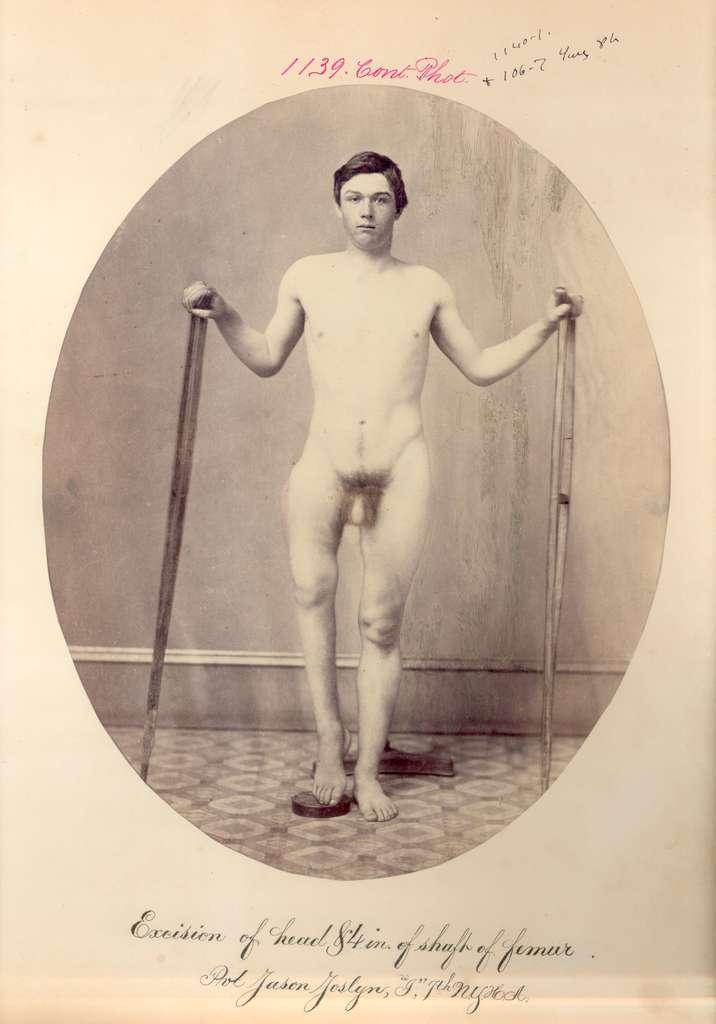How would you summarize this image in a sentence or two? In this picture I can see a man standing and he is holding walking sticks in his hands and I can see text at the bottom of the picture and I can see written text at the top of the picture. 